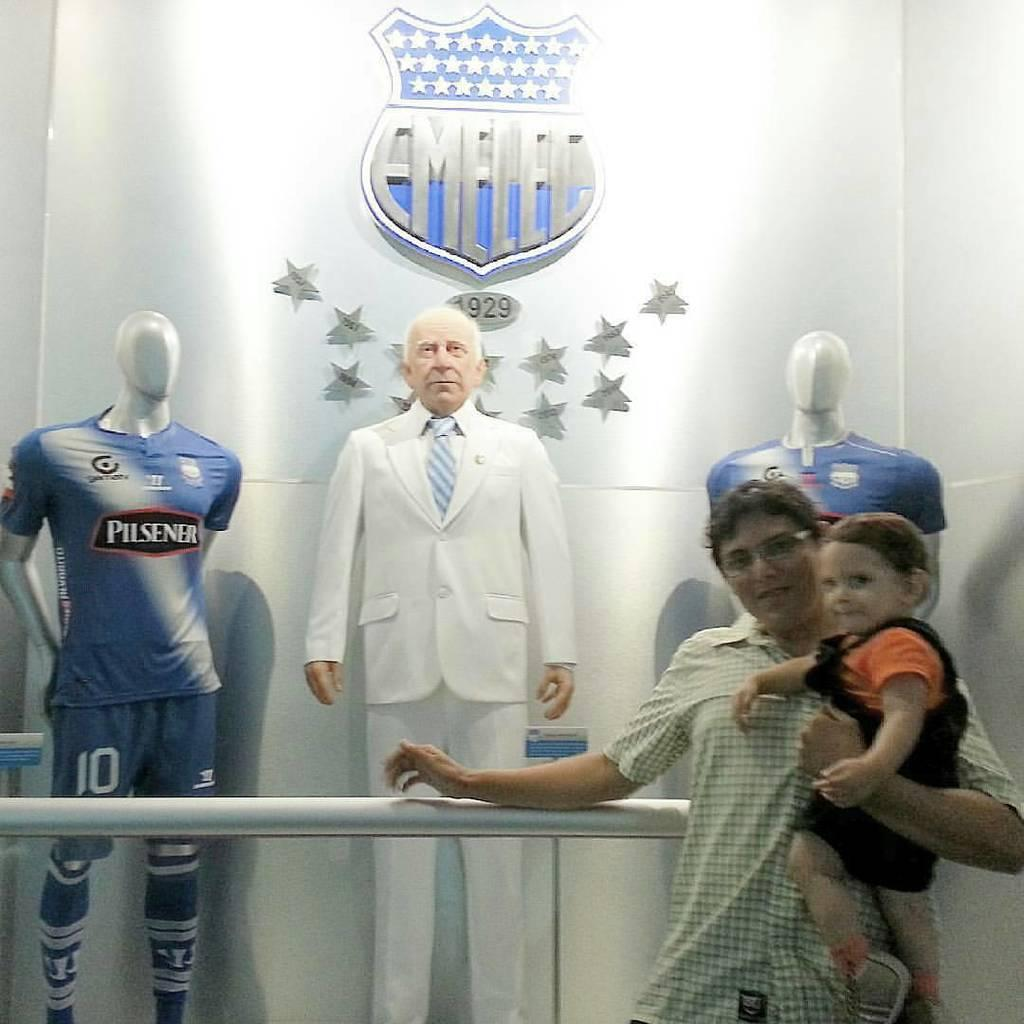<image>
Give a short and clear explanation of the subsequent image. A woman is holding a baby by a statue of a man and mannequins wearing jerseys that say Pilsner. 